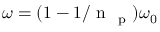Convert formula to latex. <formula><loc_0><loc_0><loc_500><loc_500>\omega = ( 1 - 1 / n _ { p } ) \omega _ { 0 }</formula> 